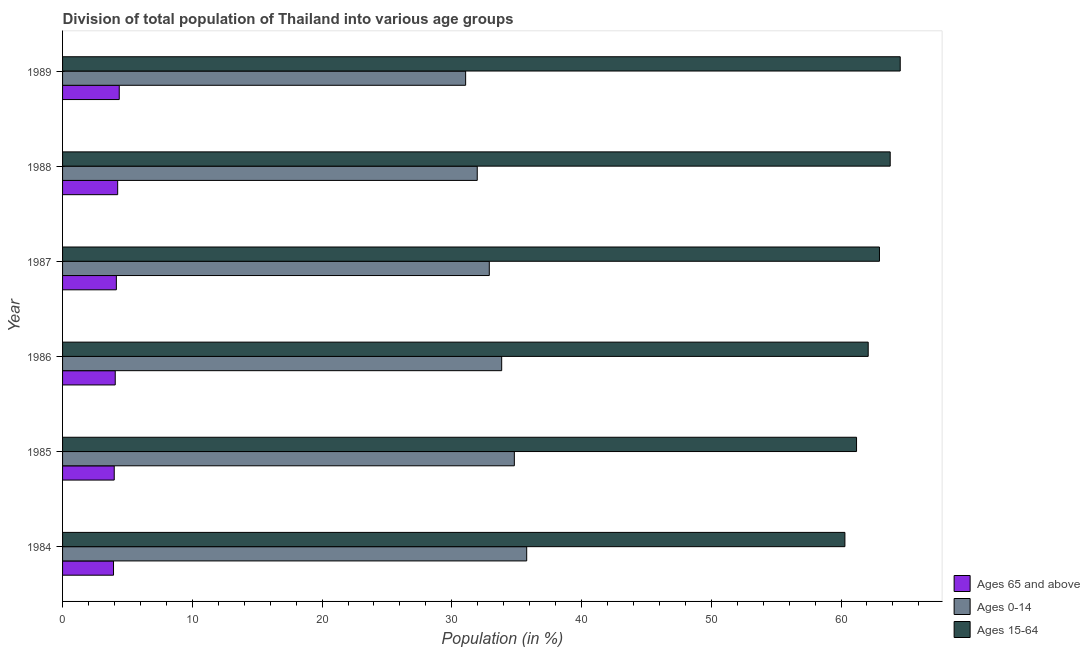How many different coloured bars are there?
Your response must be concise. 3. How many groups of bars are there?
Offer a terse response. 6. How many bars are there on the 6th tick from the top?
Ensure brevity in your answer.  3. What is the label of the 2nd group of bars from the top?
Your answer should be very brief. 1988. What is the percentage of population within the age-group 15-64 in 1985?
Make the answer very short. 61.2. Across all years, what is the maximum percentage of population within the age-group 0-14?
Your answer should be very brief. 35.77. Across all years, what is the minimum percentage of population within the age-group 0-14?
Provide a succinct answer. 31.07. In which year was the percentage of population within the age-group 0-14 maximum?
Ensure brevity in your answer.  1984. What is the total percentage of population within the age-group of 65 and above in the graph?
Provide a short and direct response. 24.73. What is the difference between the percentage of population within the age-group 15-64 in 1984 and that in 1986?
Keep it short and to the point. -1.8. What is the difference between the percentage of population within the age-group 0-14 in 1988 and the percentage of population within the age-group of 65 and above in 1989?
Your response must be concise. 27.59. What is the average percentage of population within the age-group 0-14 per year?
Provide a succinct answer. 33.39. In the year 1989, what is the difference between the percentage of population within the age-group of 65 and above and percentage of population within the age-group 0-14?
Offer a terse response. -26.7. What is the ratio of the percentage of population within the age-group 15-64 in 1986 to that in 1987?
Make the answer very short. 0.99. Is the percentage of population within the age-group of 65 and above in 1985 less than that in 1987?
Your answer should be compact. Yes. Is the difference between the percentage of population within the age-group 15-64 in 1986 and 1987 greater than the difference between the percentage of population within the age-group 0-14 in 1986 and 1987?
Offer a very short reply. No. What is the difference between the highest and the second highest percentage of population within the age-group 0-14?
Your answer should be very brief. 0.95. What is the difference between the highest and the lowest percentage of population within the age-group 0-14?
Your response must be concise. 4.71. In how many years, is the percentage of population within the age-group of 65 and above greater than the average percentage of population within the age-group of 65 and above taken over all years?
Your answer should be very brief. 3. What does the 3rd bar from the top in 1989 represents?
Offer a terse response. Ages 65 and above. What does the 2nd bar from the bottom in 1985 represents?
Your response must be concise. Ages 0-14. Is it the case that in every year, the sum of the percentage of population within the age-group of 65 and above and percentage of population within the age-group 0-14 is greater than the percentage of population within the age-group 15-64?
Provide a short and direct response. No. Are all the bars in the graph horizontal?
Offer a terse response. Yes. How many years are there in the graph?
Give a very brief answer. 6. What is the difference between two consecutive major ticks on the X-axis?
Your answer should be compact. 10. Does the graph contain any zero values?
Offer a terse response. No. Does the graph contain grids?
Keep it short and to the point. No. What is the title of the graph?
Keep it short and to the point. Division of total population of Thailand into various age groups
. Does "Textiles and clothing" appear as one of the legend labels in the graph?
Ensure brevity in your answer.  No. What is the Population (in %) of Ages 65 and above in 1984?
Provide a short and direct response. 3.93. What is the Population (in %) of Ages 0-14 in 1984?
Ensure brevity in your answer.  35.77. What is the Population (in %) of Ages 15-64 in 1984?
Make the answer very short. 60.3. What is the Population (in %) of Ages 65 and above in 1985?
Your answer should be very brief. 3.98. What is the Population (in %) of Ages 0-14 in 1985?
Your answer should be compact. 34.82. What is the Population (in %) in Ages 15-64 in 1985?
Your answer should be very brief. 61.2. What is the Population (in %) in Ages 65 and above in 1986?
Provide a short and direct response. 4.06. What is the Population (in %) in Ages 0-14 in 1986?
Ensure brevity in your answer.  33.85. What is the Population (in %) of Ages 15-64 in 1986?
Your answer should be very brief. 62.09. What is the Population (in %) of Ages 65 and above in 1987?
Offer a terse response. 4.15. What is the Population (in %) in Ages 0-14 in 1987?
Offer a very short reply. 32.89. What is the Population (in %) of Ages 15-64 in 1987?
Your answer should be very brief. 62.96. What is the Population (in %) of Ages 65 and above in 1988?
Provide a succinct answer. 4.25. What is the Population (in %) of Ages 0-14 in 1988?
Provide a short and direct response. 31.96. What is the Population (in %) of Ages 15-64 in 1988?
Make the answer very short. 63.79. What is the Population (in %) in Ages 65 and above in 1989?
Make the answer very short. 4.37. What is the Population (in %) in Ages 0-14 in 1989?
Ensure brevity in your answer.  31.07. What is the Population (in %) of Ages 15-64 in 1989?
Your answer should be compact. 64.56. Across all years, what is the maximum Population (in %) in Ages 65 and above?
Make the answer very short. 4.37. Across all years, what is the maximum Population (in %) of Ages 0-14?
Keep it short and to the point. 35.77. Across all years, what is the maximum Population (in %) of Ages 15-64?
Your answer should be compact. 64.56. Across all years, what is the minimum Population (in %) in Ages 65 and above?
Your response must be concise. 3.93. Across all years, what is the minimum Population (in %) of Ages 0-14?
Provide a succinct answer. 31.07. Across all years, what is the minimum Population (in %) of Ages 15-64?
Provide a short and direct response. 60.3. What is the total Population (in %) in Ages 65 and above in the graph?
Make the answer very short. 24.73. What is the total Population (in %) of Ages 0-14 in the graph?
Provide a succinct answer. 200.36. What is the total Population (in %) of Ages 15-64 in the graph?
Provide a short and direct response. 374.91. What is the difference between the Population (in %) in Ages 65 and above in 1984 and that in 1985?
Your answer should be compact. -0.06. What is the difference between the Population (in %) in Ages 0-14 in 1984 and that in 1985?
Make the answer very short. 0.95. What is the difference between the Population (in %) of Ages 15-64 in 1984 and that in 1985?
Provide a short and direct response. -0.9. What is the difference between the Population (in %) of Ages 65 and above in 1984 and that in 1986?
Ensure brevity in your answer.  -0.13. What is the difference between the Population (in %) of Ages 0-14 in 1984 and that in 1986?
Keep it short and to the point. 1.93. What is the difference between the Population (in %) in Ages 15-64 in 1984 and that in 1986?
Give a very brief answer. -1.8. What is the difference between the Population (in %) in Ages 65 and above in 1984 and that in 1987?
Your response must be concise. -0.22. What is the difference between the Population (in %) in Ages 0-14 in 1984 and that in 1987?
Provide a short and direct response. 2.88. What is the difference between the Population (in %) of Ages 15-64 in 1984 and that in 1987?
Give a very brief answer. -2.66. What is the difference between the Population (in %) of Ages 65 and above in 1984 and that in 1988?
Ensure brevity in your answer.  -0.32. What is the difference between the Population (in %) of Ages 0-14 in 1984 and that in 1988?
Keep it short and to the point. 3.81. What is the difference between the Population (in %) of Ages 15-64 in 1984 and that in 1988?
Offer a very short reply. -3.49. What is the difference between the Population (in %) in Ages 65 and above in 1984 and that in 1989?
Your response must be concise. -0.44. What is the difference between the Population (in %) of Ages 0-14 in 1984 and that in 1989?
Your response must be concise. 4.71. What is the difference between the Population (in %) in Ages 15-64 in 1984 and that in 1989?
Offer a terse response. -4.26. What is the difference between the Population (in %) in Ages 65 and above in 1985 and that in 1986?
Provide a short and direct response. -0.08. What is the difference between the Population (in %) of Ages 0-14 in 1985 and that in 1986?
Offer a terse response. 0.98. What is the difference between the Population (in %) in Ages 15-64 in 1985 and that in 1986?
Keep it short and to the point. -0.9. What is the difference between the Population (in %) of Ages 65 and above in 1985 and that in 1987?
Your answer should be very brief. -0.16. What is the difference between the Population (in %) in Ages 0-14 in 1985 and that in 1987?
Keep it short and to the point. 1.93. What is the difference between the Population (in %) in Ages 15-64 in 1985 and that in 1987?
Your response must be concise. -1.77. What is the difference between the Population (in %) of Ages 65 and above in 1985 and that in 1988?
Ensure brevity in your answer.  -0.26. What is the difference between the Population (in %) of Ages 0-14 in 1985 and that in 1988?
Keep it short and to the point. 2.86. What is the difference between the Population (in %) in Ages 15-64 in 1985 and that in 1988?
Offer a terse response. -2.59. What is the difference between the Population (in %) of Ages 65 and above in 1985 and that in 1989?
Your answer should be compact. -0.39. What is the difference between the Population (in %) in Ages 0-14 in 1985 and that in 1989?
Offer a very short reply. 3.75. What is the difference between the Population (in %) of Ages 15-64 in 1985 and that in 1989?
Your answer should be compact. -3.37. What is the difference between the Population (in %) in Ages 65 and above in 1986 and that in 1987?
Make the answer very short. -0.09. What is the difference between the Population (in %) in Ages 0-14 in 1986 and that in 1987?
Your answer should be very brief. 0.95. What is the difference between the Population (in %) of Ages 15-64 in 1986 and that in 1987?
Your answer should be compact. -0.87. What is the difference between the Population (in %) in Ages 65 and above in 1986 and that in 1988?
Make the answer very short. -0.19. What is the difference between the Population (in %) of Ages 0-14 in 1986 and that in 1988?
Your answer should be compact. 1.88. What is the difference between the Population (in %) of Ages 15-64 in 1986 and that in 1988?
Your answer should be compact. -1.7. What is the difference between the Population (in %) of Ages 65 and above in 1986 and that in 1989?
Your answer should be very brief. -0.31. What is the difference between the Population (in %) of Ages 0-14 in 1986 and that in 1989?
Ensure brevity in your answer.  2.78. What is the difference between the Population (in %) of Ages 15-64 in 1986 and that in 1989?
Give a very brief answer. -2.47. What is the difference between the Population (in %) in Ages 65 and above in 1987 and that in 1988?
Offer a very short reply. -0.1. What is the difference between the Population (in %) of Ages 0-14 in 1987 and that in 1988?
Provide a succinct answer. 0.93. What is the difference between the Population (in %) of Ages 15-64 in 1987 and that in 1988?
Give a very brief answer. -0.83. What is the difference between the Population (in %) of Ages 65 and above in 1987 and that in 1989?
Ensure brevity in your answer.  -0.22. What is the difference between the Population (in %) in Ages 0-14 in 1987 and that in 1989?
Your response must be concise. 1.82. What is the difference between the Population (in %) in Ages 15-64 in 1987 and that in 1989?
Offer a very short reply. -1.6. What is the difference between the Population (in %) in Ages 65 and above in 1988 and that in 1989?
Offer a terse response. -0.12. What is the difference between the Population (in %) of Ages 0-14 in 1988 and that in 1989?
Your answer should be compact. 0.9. What is the difference between the Population (in %) of Ages 15-64 in 1988 and that in 1989?
Make the answer very short. -0.77. What is the difference between the Population (in %) of Ages 65 and above in 1984 and the Population (in %) of Ages 0-14 in 1985?
Your answer should be compact. -30.89. What is the difference between the Population (in %) of Ages 65 and above in 1984 and the Population (in %) of Ages 15-64 in 1985?
Give a very brief answer. -57.27. What is the difference between the Population (in %) of Ages 0-14 in 1984 and the Population (in %) of Ages 15-64 in 1985?
Offer a terse response. -25.42. What is the difference between the Population (in %) of Ages 65 and above in 1984 and the Population (in %) of Ages 0-14 in 1986?
Your answer should be compact. -29.92. What is the difference between the Population (in %) in Ages 65 and above in 1984 and the Population (in %) in Ages 15-64 in 1986?
Provide a succinct answer. -58.17. What is the difference between the Population (in %) in Ages 0-14 in 1984 and the Population (in %) in Ages 15-64 in 1986?
Provide a short and direct response. -26.32. What is the difference between the Population (in %) of Ages 65 and above in 1984 and the Population (in %) of Ages 0-14 in 1987?
Keep it short and to the point. -28.96. What is the difference between the Population (in %) of Ages 65 and above in 1984 and the Population (in %) of Ages 15-64 in 1987?
Give a very brief answer. -59.04. What is the difference between the Population (in %) of Ages 0-14 in 1984 and the Population (in %) of Ages 15-64 in 1987?
Provide a short and direct response. -27.19. What is the difference between the Population (in %) of Ages 65 and above in 1984 and the Population (in %) of Ages 0-14 in 1988?
Offer a very short reply. -28.04. What is the difference between the Population (in %) of Ages 65 and above in 1984 and the Population (in %) of Ages 15-64 in 1988?
Offer a terse response. -59.86. What is the difference between the Population (in %) in Ages 0-14 in 1984 and the Population (in %) in Ages 15-64 in 1988?
Provide a short and direct response. -28.02. What is the difference between the Population (in %) in Ages 65 and above in 1984 and the Population (in %) in Ages 0-14 in 1989?
Your answer should be very brief. -27.14. What is the difference between the Population (in %) of Ages 65 and above in 1984 and the Population (in %) of Ages 15-64 in 1989?
Offer a very short reply. -60.64. What is the difference between the Population (in %) of Ages 0-14 in 1984 and the Population (in %) of Ages 15-64 in 1989?
Offer a very short reply. -28.79. What is the difference between the Population (in %) in Ages 65 and above in 1985 and the Population (in %) in Ages 0-14 in 1986?
Give a very brief answer. -29.86. What is the difference between the Population (in %) in Ages 65 and above in 1985 and the Population (in %) in Ages 15-64 in 1986?
Offer a very short reply. -58.11. What is the difference between the Population (in %) in Ages 0-14 in 1985 and the Population (in %) in Ages 15-64 in 1986?
Your answer should be very brief. -27.27. What is the difference between the Population (in %) of Ages 65 and above in 1985 and the Population (in %) of Ages 0-14 in 1987?
Your answer should be compact. -28.91. What is the difference between the Population (in %) in Ages 65 and above in 1985 and the Population (in %) in Ages 15-64 in 1987?
Your response must be concise. -58.98. What is the difference between the Population (in %) in Ages 0-14 in 1985 and the Population (in %) in Ages 15-64 in 1987?
Give a very brief answer. -28.14. What is the difference between the Population (in %) in Ages 65 and above in 1985 and the Population (in %) in Ages 0-14 in 1988?
Your answer should be very brief. -27.98. What is the difference between the Population (in %) of Ages 65 and above in 1985 and the Population (in %) of Ages 15-64 in 1988?
Give a very brief answer. -59.81. What is the difference between the Population (in %) of Ages 0-14 in 1985 and the Population (in %) of Ages 15-64 in 1988?
Offer a very short reply. -28.97. What is the difference between the Population (in %) of Ages 65 and above in 1985 and the Population (in %) of Ages 0-14 in 1989?
Make the answer very short. -27.08. What is the difference between the Population (in %) of Ages 65 and above in 1985 and the Population (in %) of Ages 15-64 in 1989?
Provide a short and direct response. -60.58. What is the difference between the Population (in %) of Ages 0-14 in 1985 and the Population (in %) of Ages 15-64 in 1989?
Ensure brevity in your answer.  -29.74. What is the difference between the Population (in %) in Ages 65 and above in 1986 and the Population (in %) in Ages 0-14 in 1987?
Offer a very short reply. -28.83. What is the difference between the Population (in %) of Ages 65 and above in 1986 and the Population (in %) of Ages 15-64 in 1987?
Make the answer very short. -58.9. What is the difference between the Population (in %) in Ages 0-14 in 1986 and the Population (in %) in Ages 15-64 in 1987?
Give a very brief answer. -29.12. What is the difference between the Population (in %) of Ages 65 and above in 1986 and the Population (in %) of Ages 0-14 in 1988?
Keep it short and to the point. -27.9. What is the difference between the Population (in %) in Ages 65 and above in 1986 and the Population (in %) in Ages 15-64 in 1988?
Provide a short and direct response. -59.73. What is the difference between the Population (in %) of Ages 0-14 in 1986 and the Population (in %) of Ages 15-64 in 1988?
Your answer should be very brief. -29.95. What is the difference between the Population (in %) in Ages 65 and above in 1986 and the Population (in %) in Ages 0-14 in 1989?
Ensure brevity in your answer.  -27.01. What is the difference between the Population (in %) of Ages 65 and above in 1986 and the Population (in %) of Ages 15-64 in 1989?
Offer a terse response. -60.5. What is the difference between the Population (in %) in Ages 0-14 in 1986 and the Population (in %) in Ages 15-64 in 1989?
Offer a terse response. -30.72. What is the difference between the Population (in %) of Ages 65 and above in 1987 and the Population (in %) of Ages 0-14 in 1988?
Give a very brief answer. -27.82. What is the difference between the Population (in %) in Ages 65 and above in 1987 and the Population (in %) in Ages 15-64 in 1988?
Offer a terse response. -59.64. What is the difference between the Population (in %) of Ages 0-14 in 1987 and the Population (in %) of Ages 15-64 in 1988?
Give a very brief answer. -30.9. What is the difference between the Population (in %) of Ages 65 and above in 1987 and the Population (in %) of Ages 0-14 in 1989?
Keep it short and to the point. -26.92. What is the difference between the Population (in %) of Ages 65 and above in 1987 and the Population (in %) of Ages 15-64 in 1989?
Your response must be concise. -60.42. What is the difference between the Population (in %) of Ages 0-14 in 1987 and the Population (in %) of Ages 15-64 in 1989?
Your answer should be very brief. -31.67. What is the difference between the Population (in %) of Ages 65 and above in 1988 and the Population (in %) of Ages 0-14 in 1989?
Make the answer very short. -26.82. What is the difference between the Population (in %) of Ages 65 and above in 1988 and the Population (in %) of Ages 15-64 in 1989?
Provide a succinct answer. -60.32. What is the difference between the Population (in %) of Ages 0-14 in 1988 and the Population (in %) of Ages 15-64 in 1989?
Ensure brevity in your answer.  -32.6. What is the average Population (in %) in Ages 65 and above per year?
Make the answer very short. 4.12. What is the average Population (in %) in Ages 0-14 per year?
Your answer should be very brief. 33.39. What is the average Population (in %) of Ages 15-64 per year?
Give a very brief answer. 62.48. In the year 1984, what is the difference between the Population (in %) in Ages 65 and above and Population (in %) in Ages 0-14?
Offer a terse response. -31.85. In the year 1984, what is the difference between the Population (in %) in Ages 65 and above and Population (in %) in Ages 15-64?
Provide a short and direct response. -56.37. In the year 1984, what is the difference between the Population (in %) in Ages 0-14 and Population (in %) in Ages 15-64?
Offer a terse response. -24.53. In the year 1985, what is the difference between the Population (in %) of Ages 65 and above and Population (in %) of Ages 0-14?
Your answer should be very brief. -30.84. In the year 1985, what is the difference between the Population (in %) of Ages 65 and above and Population (in %) of Ages 15-64?
Provide a short and direct response. -57.21. In the year 1985, what is the difference between the Population (in %) in Ages 0-14 and Population (in %) in Ages 15-64?
Offer a very short reply. -26.38. In the year 1986, what is the difference between the Population (in %) in Ages 65 and above and Population (in %) in Ages 0-14?
Provide a succinct answer. -29.79. In the year 1986, what is the difference between the Population (in %) in Ages 65 and above and Population (in %) in Ages 15-64?
Provide a succinct answer. -58.03. In the year 1986, what is the difference between the Population (in %) in Ages 0-14 and Population (in %) in Ages 15-64?
Keep it short and to the point. -28.25. In the year 1987, what is the difference between the Population (in %) of Ages 65 and above and Population (in %) of Ages 0-14?
Ensure brevity in your answer.  -28.74. In the year 1987, what is the difference between the Population (in %) of Ages 65 and above and Population (in %) of Ages 15-64?
Give a very brief answer. -58.82. In the year 1987, what is the difference between the Population (in %) in Ages 0-14 and Population (in %) in Ages 15-64?
Provide a succinct answer. -30.07. In the year 1988, what is the difference between the Population (in %) of Ages 65 and above and Population (in %) of Ages 0-14?
Keep it short and to the point. -27.72. In the year 1988, what is the difference between the Population (in %) in Ages 65 and above and Population (in %) in Ages 15-64?
Offer a very short reply. -59.54. In the year 1988, what is the difference between the Population (in %) in Ages 0-14 and Population (in %) in Ages 15-64?
Your answer should be very brief. -31.83. In the year 1989, what is the difference between the Population (in %) of Ages 65 and above and Population (in %) of Ages 0-14?
Your response must be concise. -26.7. In the year 1989, what is the difference between the Population (in %) of Ages 65 and above and Population (in %) of Ages 15-64?
Give a very brief answer. -60.19. In the year 1989, what is the difference between the Population (in %) of Ages 0-14 and Population (in %) of Ages 15-64?
Provide a short and direct response. -33.5. What is the ratio of the Population (in %) of Ages 65 and above in 1984 to that in 1985?
Provide a short and direct response. 0.99. What is the ratio of the Population (in %) of Ages 0-14 in 1984 to that in 1985?
Keep it short and to the point. 1.03. What is the ratio of the Population (in %) in Ages 65 and above in 1984 to that in 1986?
Your answer should be compact. 0.97. What is the ratio of the Population (in %) in Ages 0-14 in 1984 to that in 1986?
Offer a very short reply. 1.06. What is the ratio of the Population (in %) in Ages 15-64 in 1984 to that in 1986?
Give a very brief answer. 0.97. What is the ratio of the Population (in %) of Ages 65 and above in 1984 to that in 1987?
Provide a succinct answer. 0.95. What is the ratio of the Population (in %) of Ages 0-14 in 1984 to that in 1987?
Make the answer very short. 1.09. What is the ratio of the Population (in %) of Ages 15-64 in 1984 to that in 1987?
Keep it short and to the point. 0.96. What is the ratio of the Population (in %) in Ages 65 and above in 1984 to that in 1988?
Offer a very short reply. 0.92. What is the ratio of the Population (in %) in Ages 0-14 in 1984 to that in 1988?
Your answer should be compact. 1.12. What is the ratio of the Population (in %) of Ages 15-64 in 1984 to that in 1988?
Your answer should be compact. 0.95. What is the ratio of the Population (in %) in Ages 65 and above in 1984 to that in 1989?
Provide a succinct answer. 0.9. What is the ratio of the Population (in %) of Ages 0-14 in 1984 to that in 1989?
Make the answer very short. 1.15. What is the ratio of the Population (in %) of Ages 15-64 in 1984 to that in 1989?
Keep it short and to the point. 0.93. What is the ratio of the Population (in %) in Ages 0-14 in 1985 to that in 1986?
Offer a terse response. 1.03. What is the ratio of the Population (in %) of Ages 15-64 in 1985 to that in 1986?
Your answer should be very brief. 0.99. What is the ratio of the Population (in %) of Ages 65 and above in 1985 to that in 1987?
Offer a very short reply. 0.96. What is the ratio of the Population (in %) of Ages 0-14 in 1985 to that in 1987?
Keep it short and to the point. 1.06. What is the ratio of the Population (in %) of Ages 15-64 in 1985 to that in 1987?
Give a very brief answer. 0.97. What is the ratio of the Population (in %) of Ages 65 and above in 1985 to that in 1988?
Make the answer very short. 0.94. What is the ratio of the Population (in %) of Ages 0-14 in 1985 to that in 1988?
Offer a terse response. 1.09. What is the ratio of the Population (in %) in Ages 15-64 in 1985 to that in 1988?
Your response must be concise. 0.96. What is the ratio of the Population (in %) of Ages 65 and above in 1985 to that in 1989?
Make the answer very short. 0.91. What is the ratio of the Population (in %) of Ages 0-14 in 1985 to that in 1989?
Your response must be concise. 1.12. What is the ratio of the Population (in %) in Ages 15-64 in 1985 to that in 1989?
Provide a short and direct response. 0.95. What is the ratio of the Population (in %) of Ages 65 and above in 1986 to that in 1987?
Offer a very short reply. 0.98. What is the ratio of the Population (in %) in Ages 0-14 in 1986 to that in 1987?
Make the answer very short. 1.03. What is the ratio of the Population (in %) in Ages 15-64 in 1986 to that in 1987?
Offer a very short reply. 0.99. What is the ratio of the Population (in %) in Ages 65 and above in 1986 to that in 1988?
Offer a terse response. 0.96. What is the ratio of the Population (in %) of Ages 0-14 in 1986 to that in 1988?
Your answer should be very brief. 1.06. What is the ratio of the Population (in %) of Ages 15-64 in 1986 to that in 1988?
Offer a terse response. 0.97. What is the ratio of the Population (in %) in Ages 65 and above in 1986 to that in 1989?
Provide a short and direct response. 0.93. What is the ratio of the Population (in %) in Ages 0-14 in 1986 to that in 1989?
Offer a very short reply. 1.09. What is the ratio of the Population (in %) in Ages 15-64 in 1986 to that in 1989?
Keep it short and to the point. 0.96. What is the ratio of the Population (in %) in Ages 65 and above in 1987 to that in 1988?
Your answer should be compact. 0.98. What is the ratio of the Population (in %) of Ages 0-14 in 1987 to that in 1988?
Make the answer very short. 1.03. What is the ratio of the Population (in %) in Ages 15-64 in 1987 to that in 1988?
Offer a very short reply. 0.99. What is the ratio of the Population (in %) of Ages 65 and above in 1987 to that in 1989?
Your answer should be compact. 0.95. What is the ratio of the Population (in %) in Ages 0-14 in 1987 to that in 1989?
Keep it short and to the point. 1.06. What is the ratio of the Population (in %) in Ages 15-64 in 1987 to that in 1989?
Your answer should be very brief. 0.98. What is the ratio of the Population (in %) of Ages 65 and above in 1988 to that in 1989?
Keep it short and to the point. 0.97. What is the ratio of the Population (in %) of Ages 0-14 in 1988 to that in 1989?
Your answer should be very brief. 1.03. What is the ratio of the Population (in %) in Ages 15-64 in 1988 to that in 1989?
Offer a terse response. 0.99. What is the difference between the highest and the second highest Population (in %) in Ages 65 and above?
Give a very brief answer. 0.12. What is the difference between the highest and the second highest Population (in %) of Ages 0-14?
Offer a terse response. 0.95. What is the difference between the highest and the second highest Population (in %) of Ages 15-64?
Make the answer very short. 0.77. What is the difference between the highest and the lowest Population (in %) in Ages 65 and above?
Give a very brief answer. 0.44. What is the difference between the highest and the lowest Population (in %) in Ages 0-14?
Ensure brevity in your answer.  4.71. What is the difference between the highest and the lowest Population (in %) of Ages 15-64?
Offer a very short reply. 4.26. 